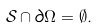<formula> <loc_0><loc_0><loc_500><loc_500>\mathcal { S } \cap \partial \Omega = \emptyset .</formula> 